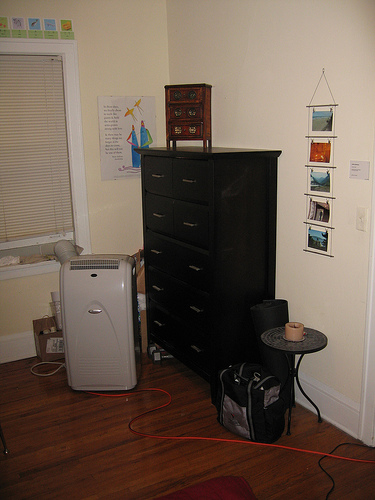<image>
Can you confirm if the pictures is next to the dresser? Yes. The pictures is positioned adjacent to the dresser, located nearby in the same general area. Is the candle on the dresser? No. The candle is not positioned on the dresser. They may be near each other, but the candle is not supported by or resting on top of the dresser. 